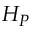<formula> <loc_0><loc_0><loc_500><loc_500>H _ { P }</formula> 